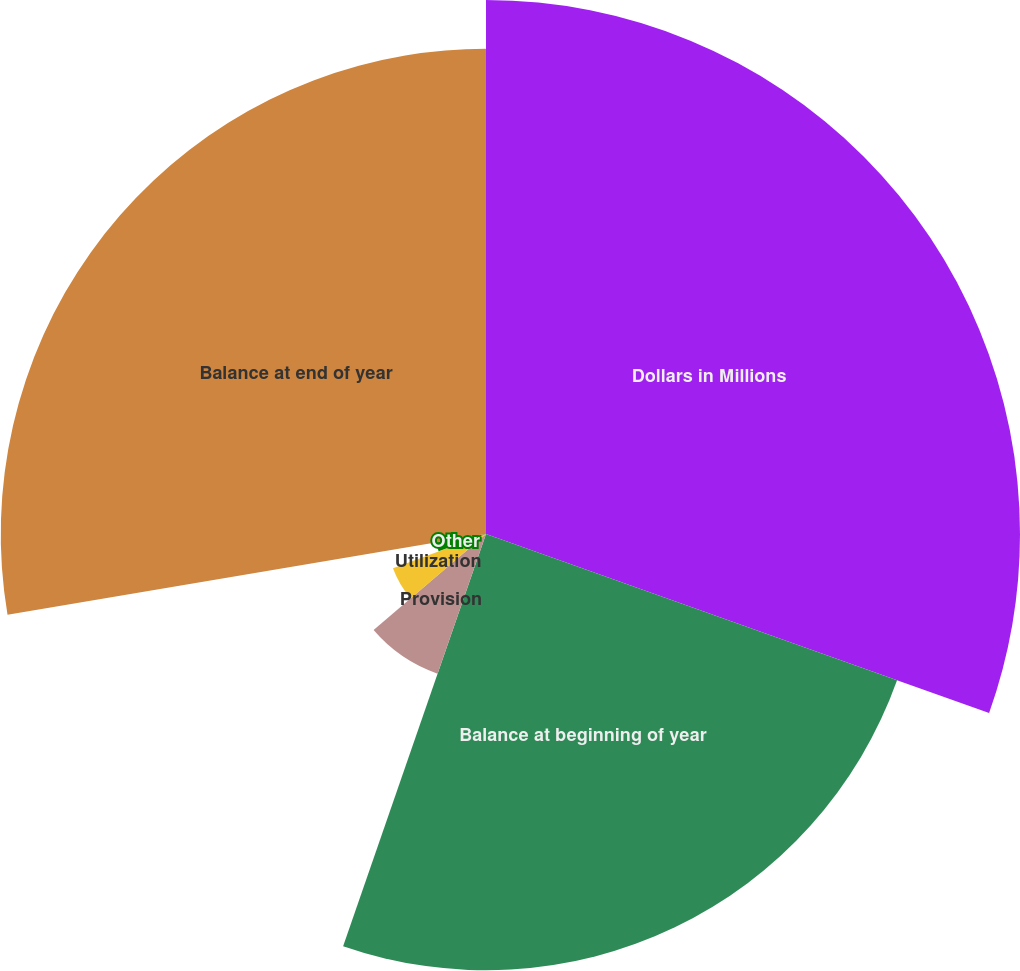<chart> <loc_0><loc_0><loc_500><loc_500><pie_chart><fcel>Dollars in Millions<fcel>Balance at beginning of year<fcel>Provision<fcel>Utilization<fcel>Foreign currency translation<fcel>Other<fcel>Balance at end of year<nl><fcel>30.44%<fcel>24.87%<fcel>8.43%<fcel>5.65%<fcel>0.08%<fcel>2.87%<fcel>27.66%<nl></chart> 